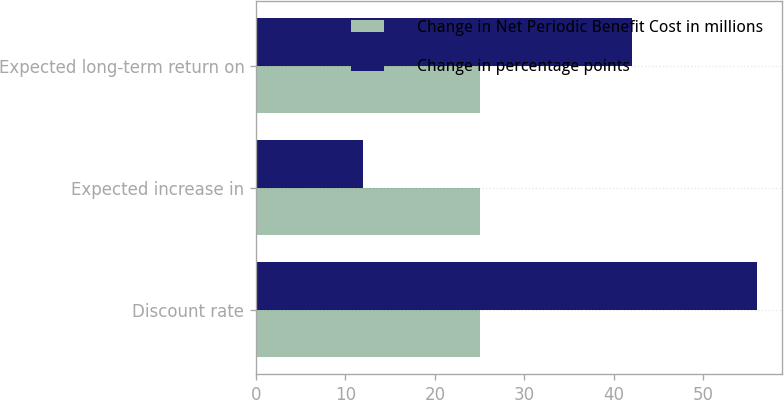<chart> <loc_0><loc_0><loc_500><loc_500><stacked_bar_chart><ecel><fcel>Discount rate<fcel>Expected increase in<fcel>Expected long-term return on<nl><fcel>Change in Net Periodic Benefit Cost in millions<fcel>25<fcel>25<fcel>25<nl><fcel>Change in percentage points<fcel>56<fcel>12<fcel>42<nl></chart> 